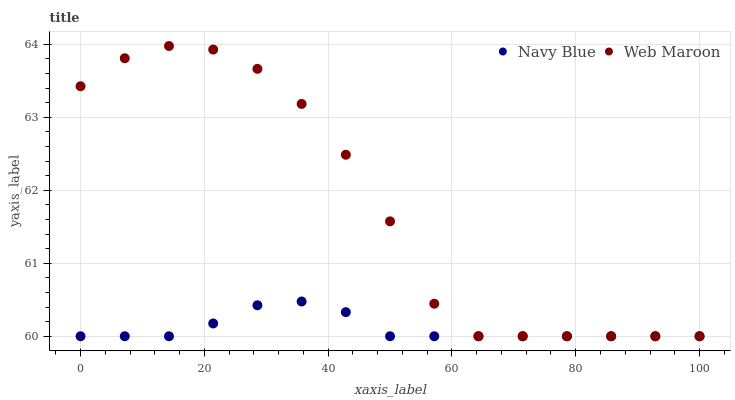Does Navy Blue have the minimum area under the curve?
Answer yes or no. Yes. Does Web Maroon have the maximum area under the curve?
Answer yes or no. Yes. Does Web Maroon have the minimum area under the curve?
Answer yes or no. No. Is Navy Blue the smoothest?
Answer yes or no. Yes. Is Web Maroon the roughest?
Answer yes or no. Yes. Is Web Maroon the smoothest?
Answer yes or no. No. Does Navy Blue have the lowest value?
Answer yes or no. Yes. Does Web Maroon have the highest value?
Answer yes or no. Yes. Does Navy Blue intersect Web Maroon?
Answer yes or no. Yes. Is Navy Blue less than Web Maroon?
Answer yes or no. No. Is Navy Blue greater than Web Maroon?
Answer yes or no. No. 